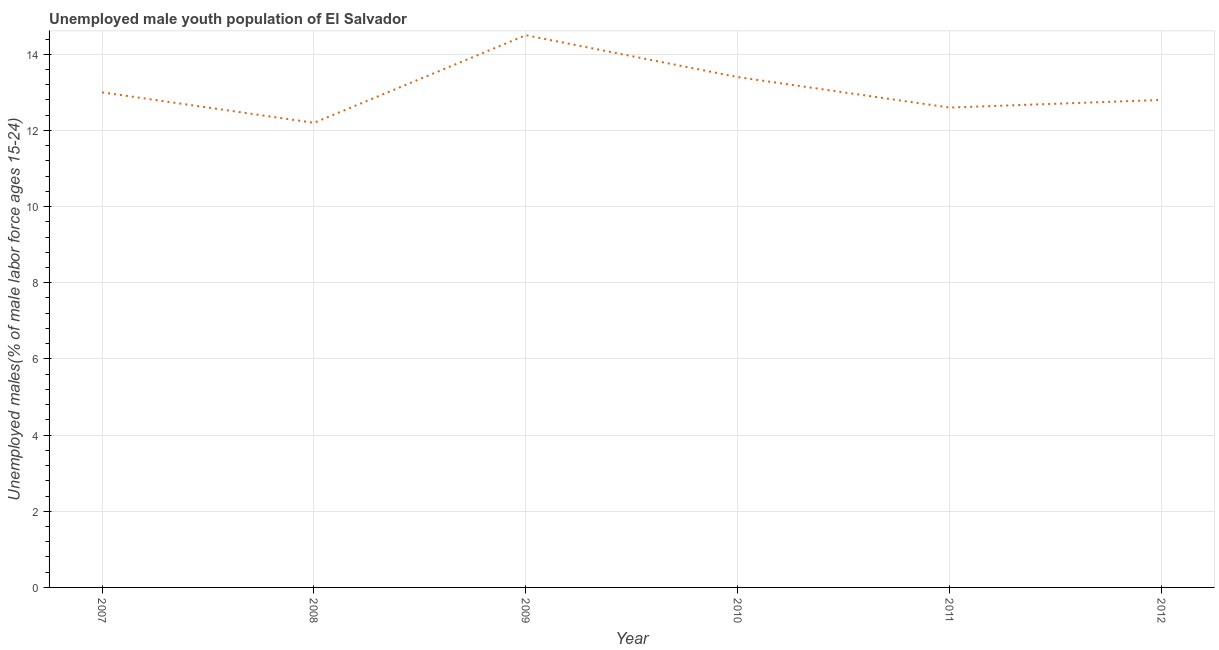What is the unemployed male youth in 2007?
Ensure brevity in your answer.  13. Across all years, what is the minimum unemployed male youth?
Offer a very short reply. 12.2. In which year was the unemployed male youth maximum?
Provide a succinct answer. 2009. In which year was the unemployed male youth minimum?
Offer a very short reply. 2008. What is the sum of the unemployed male youth?
Ensure brevity in your answer.  78.5. What is the difference between the unemployed male youth in 2007 and 2009?
Provide a succinct answer. -1.5. What is the average unemployed male youth per year?
Your response must be concise. 13.08. What is the median unemployed male youth?
Ensure brevity in your answer.  12.9. Do a majority of the years between 2010 and 2007 (inclusive) have unemployed male youth greater than 7.2 %?
Keep it short and to the point. Yes. What is the ratio of the unemployed male youth in 2009 to that in 2011?
Ensure brevity in your answer.  1.15. Is the difference between the unemployed male youth in 2010 and 2012 greater than the difference between any two years?
Offer a very short reply. No. What is the difference between the highest and the second highest unemployed male youth?
Give a very brief answer. 1.1. Is the sum of the unemployed male youth in 2007 and 2008 greater than the maximum unemployed male youth across all years?
Keep it short and to the point. Yes. What is the difference between the highest and the lowest unemployed male youth?
Give a very brief answer. 2.3. In how many years, is the unemployed male youth greater than the average unemployed male youth taken over all years?
Make the answer very short. 2. How many lines are there?
Offer a very short reply. 1. How many years are there in the graph?
Make the answer very short. 6. What is the difference between two consecutive major ticks on the Y-axis?
Your answer should be very brief. 2. Does the graph contain grids?
Your answer should be compact. Yes. What is the title of the graph?
Keep it short and to the point. Unemployed male youth population of El Salvador. What is the label or title of the X-axis?
Keep it short and to the point. Year. What is the label or title of the Y-axis?
Give a very brief answer. Unemployed males(% of male labor force ages 15-24). What is the Unemployed males(% of male labor force ages 15-24) in 2008?
Offer a very short reply. 12.2. What is the Unemployed males(% of male labor force ages 15-24) of 2010?
Make the answer very short. 13.4. What is the Unemployed males(% of male labor force ages 15-24) of 2011?
Make the answer very short. 12.6. What is the Unemployed males(% of male labor force ages 15-24) of 2012?
Keep it short and to the point. 12.8. What is the difference between the Unemployed males(% of male labor force ages 15-24) in 2007 and 2009?
Your answer should be very brief. -1.5. What is the difference between the Unemployed males(% of male labor force ages 15-24) in 2007 and 2010?
Your response must be concise. -0.4. What is the difference between the Unemployed males(% of male labor force ages 15-24) in 2007 and 2011?
Give a very brief answer. 0.4. What is the difference between the Unemployed males(% of male labor force ages 15-24) in 2007 and 2012?
Make the answer very short. 0.2. What is the difference between the Unemployed males(% of male labor force ages 15-24) in 2008 and 2009?
Ensure brevity in your answer.  -2.3. What is the difference between the Unemployed males(% of male labor force ages 15-24) in 2008 and 2010?
Your response must be concise. -1.2. What is the difference between the Unemployed males(% of male labor force ages 15-24) in 2008 and 2011?
Offer a terse response. -0.4. What is the difference between the Unemployed males(% of male labor force ages 15-24) in 2009 and 2010?
Ensure brevity in your answer.  1.1. What is the difference between the Unemployed males(% of male labor force ages 15-24) in 2010 and 2011?
Give a very brief answer. 0.8. What is the difference between the Unemployed males(% of male labor force ages 15-24) in 2011 and 2012?
Provide a succinct answer. -0.2. What is the ratio of the Unemployed males(% of male labor force ages 15-24) in 2007 to that in 2008?
Ensure brevity in your answer.  1.07. What is the ratio of the Unemployed males(% of male labor force ages 15-24) in 2007 to that in 2009?
Give a very brief answer. 0.9. What is the ratio of the Unemployed males(% of male labor force ages 15-24) in 2007 to that in 2010?
Offer a terse response. 0.97. What is the ratio of the Unemployed males(% of male labor force ages 15-24) in 2007 to that in 2011?
Ensure brevity in your answer.  1.03. What is the ratio of the Unemployed males(% of male labor force ages 15-24) in 2007 to that in 2012?
Make the answer very short. 1.02. What is the ratio of the Unemployed males(% of male labor force ages 15-24) in 2008 to that in 2009?
Provide a short and direct response. 0.84. What is the ratio of the Unemployed males(% of male labor force ages 15-24) in 2008 to that in 2010?
Your response must be concise. 0.91. What is the ratio of the Unemployed males(% of male labor force ages 15-24) in 2008 to that in 2011?
Provide a short and direct response. 0.97. What is the ratio of the Unemployed males(% of male labor force ages 15-24) in 2008 to that in 2012?
Your answer should be compact. 0.95. What is the ratio of the Unemployed males(% of male labor force ages 15-24) in 2009 to that in 2010?
Offer a very short reply. 1.08. What is the ratio of the Unemployed males(% of male labor force ages 15-24) in 2009 to that in 2011?
Ensure brevity in your answer.  1.15. What is the ratio of the Unemployed males(% of male labor force ages 15-24) in 2009 to that in 2012?
Make the answer very short. 1.13. What is the ratio of the Unemployed males(% of male labor force ages 15-24) in 2010 to that in 2011?
Provide a short and direct response. 1.06. What is the ratio of the Unemployed males(% of male labor force ages 15-24) in 2010 to that in 2012?
Give a very brief answer. 1.05. 